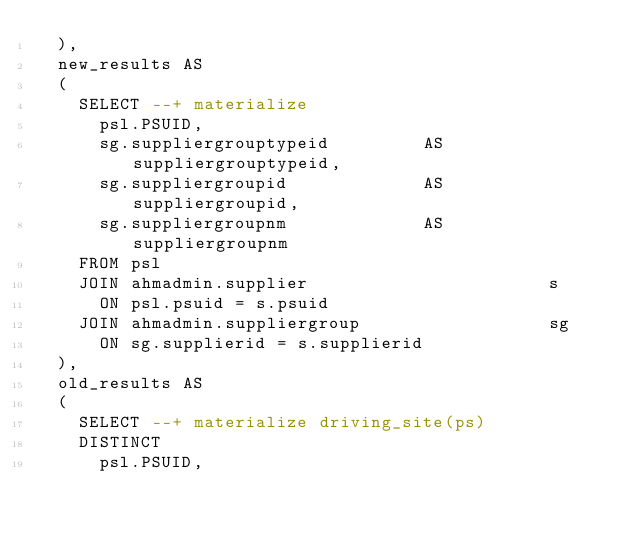Convert code to text. <code><loc_0><loc_0><loc_500><loc_500><_SQL_>  ),
  new_results AS
  (
    SELECT --+ materialize
      psl.PSUID,
      sg.suppliergrouptypeid         AS suppliergrouptypeid,
      sg.suppliergroupid             AS suppliergroupid,
      sg.suppliergroupnm             AS suppliergroupnm
    FROM psl                                     
    JOIN ahmadmin.supplier                       s
      ON psl.psuid = s.psuid 
    JOIN ahmadmin.suppliergroup                  sg
      ON sg.supplierid = s.supplierid
  ),      
  old_results AS
  (
    SELECT --+ materialize driving_site(ps)
    DISTINCT
      psl.PSUID,</code> 